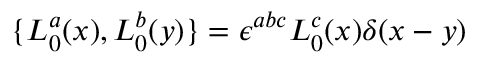<formula> <loc_0><loc_0><loc_500><loc_500>\{ L _ { 0 } ^ { a } ( x ) , L _ { 0 } ^ { b } ( y ) \} = \epsilon ^ { a b c } L _ { 0 } ^ { c } ( x ) \delta ( x - y )</formula> 